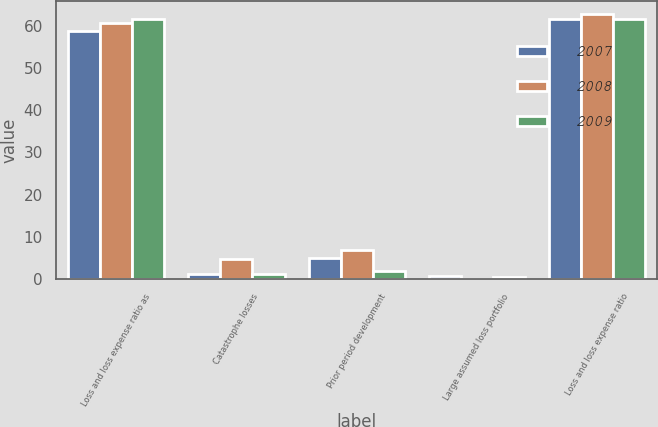Convert chart to OTSL. <chart><loc_0><loc_0><loc_500><loc_500><stacked_bar_chart><ecel><fcel>Loss and loss expense ratio as<fcel>Catastrophe losses<fcel>Prior period development<fcel>Large assumed loss portfolio<fcel>Loss and loss expense ratio<nl><fcel>2007<fcel>58.8<fcel>1.2<fcel>4.9<fcel>0.8<fcel>61.7<nl><fcel>2008<fcel>60.6<fcel>4.7<fcel>6.8<fcel>0<fcel>62.7<nl><fcel>2009<fcel>61.6<fcel>1.3<fcel>1.8<fcel>0.5<fcel>61.6<nl></chart> 